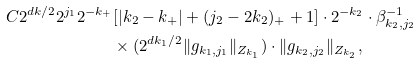<formula> <loc_0><loc_0><loc_500><loc_500>C 2 ^ { d k / 2 } 2 ^ { j _ { 1 } } 2 ^ { - k _ { + } } & [ | k _ { 2 } - k _ { + } | + ( j _ { 2 } - 2 k _ { 2 } ) _ { + } + 1 ] \cdot 2 ^ { - k _ { 2 } } \cdot \beta _ { k _ { 2 } , j _ { 2 } } ^ { - 1 } \\ & \times ( 2 ^ { d k _ { 1 } / 2 } \| g _ { k _ { 1 } , j _ { 1 } } \| _ { Z _ { k _ { 1 } } } ) \cdot \| g _ { k _ { 2 } , j _ { 2 } } \| _ { Z _ { k _ { 2 } } } ,</formula> 